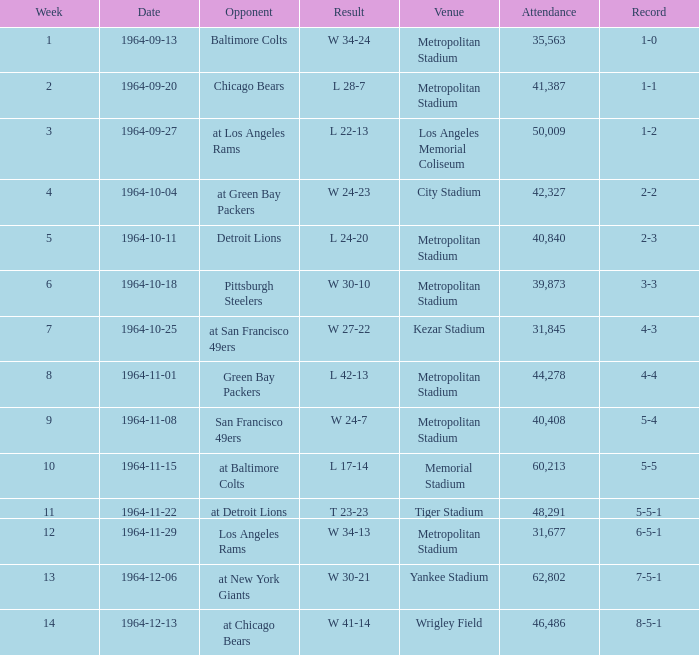What happened when the record was 1-0 and the event transpired earlier than week 4? W 34-24. 